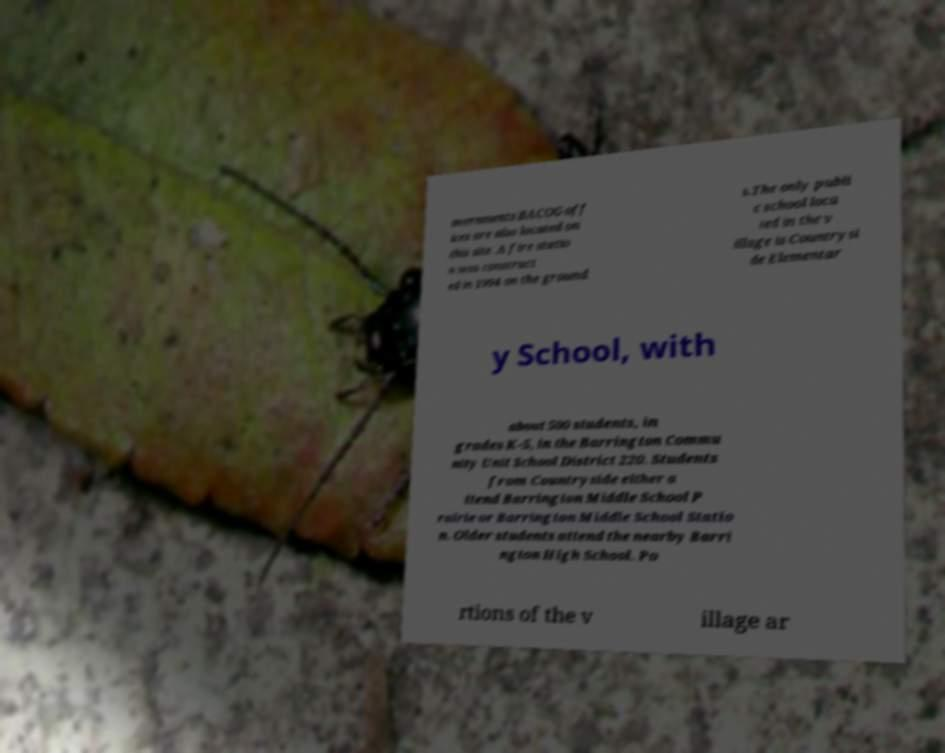For documentation purposes, I need the text within this image transcribed. Could you provide that? overnments BACOG off ices are also located on this site. A fire statio n was construct ed in 1994 on the ground s.The only publi c school loca ted in the v illage is Countrysi de Elementar y School, with about 500 students, in grades K-5, in the Barrington Commu nity Unit School District 220. Students from Countryside either a ttend Barrington Middle School P rairie or Barrington Middle School Statio n. Older students attend the nearby Barri ngton High School. Po rtions of the v illage ar 